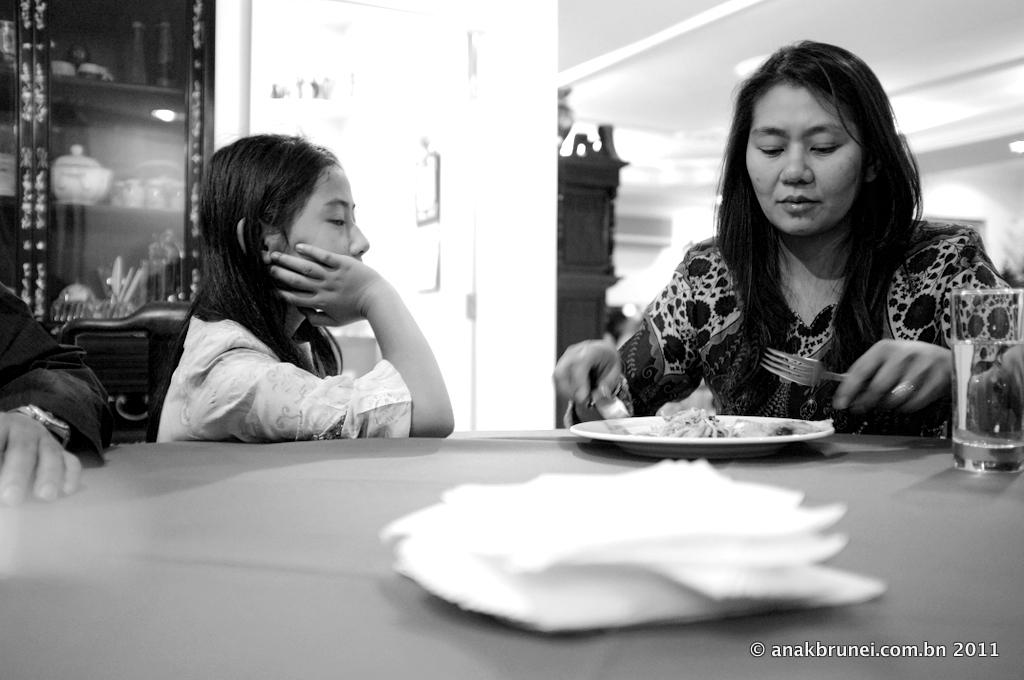How many people are in the image? There are two men in the image. What are the men doing in the image? The men are seated on chairs. What is on the table in the image? There is a plate with food and a glass on the table. How many utensils are visible in the image? There are two forks in the image. What type of army uniform can be seen on the men in the image? There is no army uniform present in the image; the men are dressed in civilian clothing. How many steps are visible in the image? There are no steps visible in the image; it features two men seated on chairs and objects on a table. 